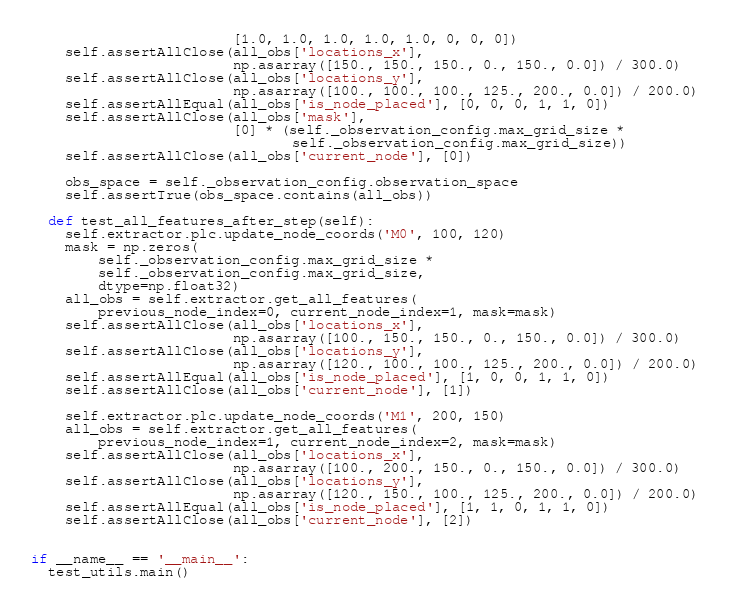<code> <loc_0><loc_0><loc_500><loc_500><_Python_>                        [1.0, 1.0, 1.0, 1.0, 1.0, 0, 0, 0])
    self.assertAllClose(all_obs['locations_x'],
                        np.asarray([150., 150., 150., 0., 150., 0.0]) / 300.0)
    self.assertAllClose(all_obs['locations_y'],
                        np.asarray([100., 100., 100., 125., 200., 0.0]) / 200.0)
    self.assertAllEqual(all_obs['is_node_placed'], [0, 0, 0, 1, 1, 0])
    self.assertAllClose(all_obs['mask'],
                        [0] * (self._observation_config.max_grid_size *
                               self._observation_config.max_grid_size))
    self.assertAllClose(all_obs['current_node'], [0])

    obs_space = self._observation_config.observation_space
    self.assertTrue(obs_space.contains(all_obs))

  def test_all_features_after_step(self):
    self.extractor.plc.update_node_coords('M0', 100, 120)
    mask = np.zeros(
        self._observation_config.max_grid_size *
        self._observation_config.max_grid_size,
        dtype=np.float32)
    all_obs = self.extractor.get_all_features(
        previous_node_index=0, current_node_index=1, mask=mask)
    self.assertAllClose(all_obs['locations_x'],
                        np.asarray([100., 150., 150., 0., 150., 0.0]) / 300.0)
    self.assertAllClose(all_obs['locations_y'],
                        np.asarray([120., 100., 100., 125., 200., 0.0]) / 200.0)
    self.assertAllEqual(all_obs['is_node_placed'], [1, 0, 0, 1, 1, 0])
    self.assertAllClose(all_obs['current_node'], [1])

    self.extractor.plc.update_node_coords('M1', 200, 150)
    all_obs = self.extractor.get_all_features(
        previous_node_index=1, current_node_index=2, mask=mask)
    self.assertAllClose(all_obs['locations_x'],
                        np.asarray([100., 200., 150., 0., 150., 0.0]) / 300.0)
    self.assertAllClose(all_obs['locations_y'],
                        np.asarray([120., 150., 100., 125., 200., 0.0]) / 200.0)
    self.assertAllEqual(all_obs['is_node_placed'], [1, 1, 0, 1, 1, 0])
    self.assertAllClose(all_obs['current_node'], [2])


if __name__ == '__main__':
  test_utils.main()
</code> 